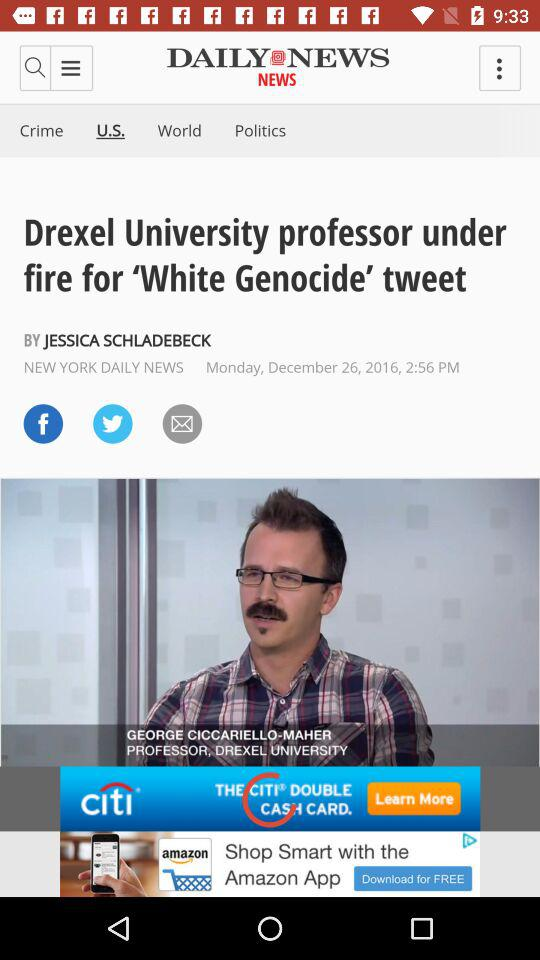How many articles are in "Politics"?
When the provided information is insufficient, respond with <no answer>. <no answer> 